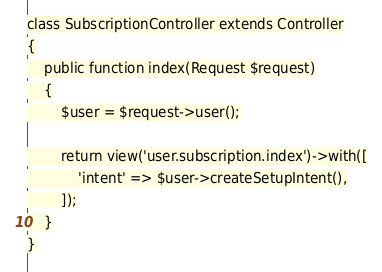Convert code to text. <code><loc_0><loc_0><loc_500><loc_500><_PHP_>
class SubscriptionController extends Controller
{
    public function index(Request $request)
    {
        $user = $request->user();

        return view('user.subscription.index')->with([
            'intent' => $user->createSetupIntent(),
        ]);
    }
}
</code> 